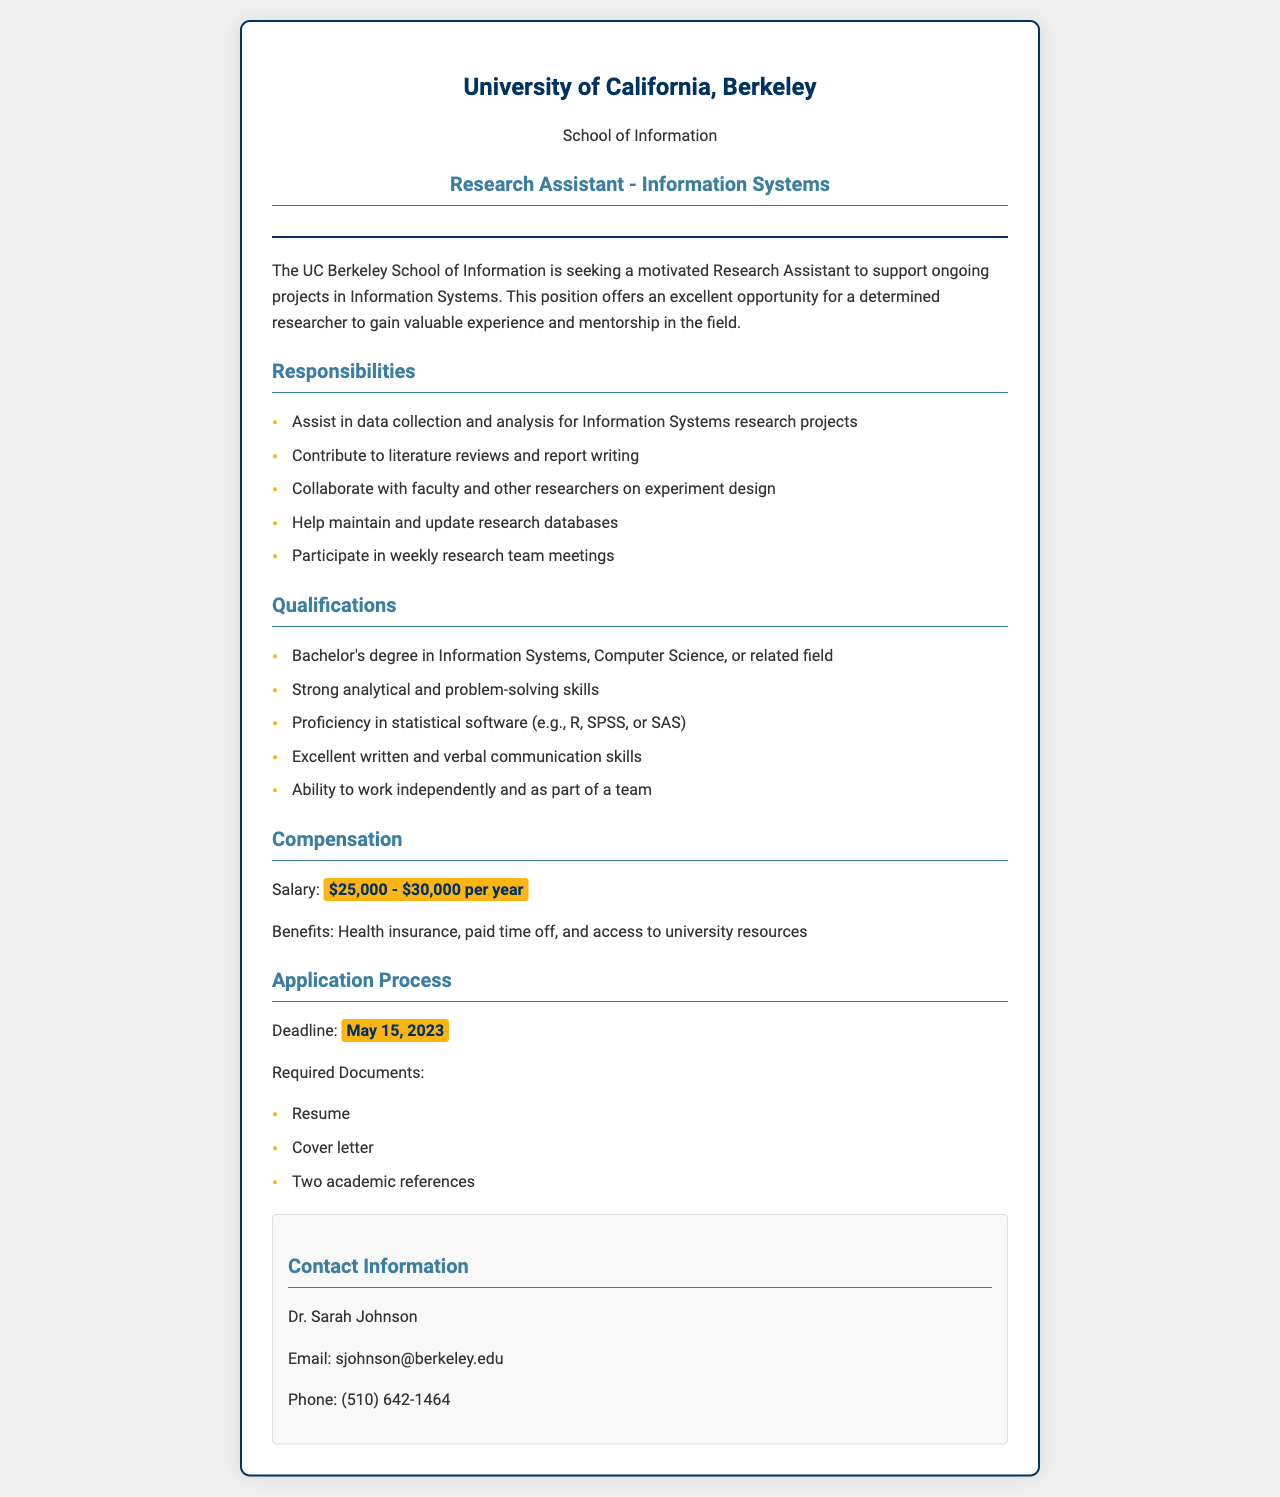what is the job title? The job title is provided in the header section of the document, which is clearly stated as Research Assistant - Information Systems.
Answer: Research Assistant - Information Systems who is the contact person? The contact person is mentioned in the contact information section, specifying the name of the individual responsible for inquiries.
Answer: Dr. Sarah Johnson what is the salary range? The salary range is provided in the compensation section of the document, detailing the expected payment for the position.
Answer: $25,000 - $30,000 per year when is the application deadline? The application deadline is highlighted in the application process section, specifying the last date applicants can submit their materials.
Answer: May 15, 2023 what is one benefit offered? Benefits are mentioned in the compensation section, where a specific type of benefit is included in the list.
Answer: Health insurance list one responsibility of the research assistant. Responsibilities are outlined in the responsibilities section, with specific tasks the assistant is expected to perform.
Answer: Assist in data collection and analysis what degree is required for this position? The qualifications section specifies the educational requirement for candidates applying for the position.
Answer: Bachelor's degree how many academic references are required? The application process section details the number of references necessary for consideration of applicants.
Answer: Two academic references 